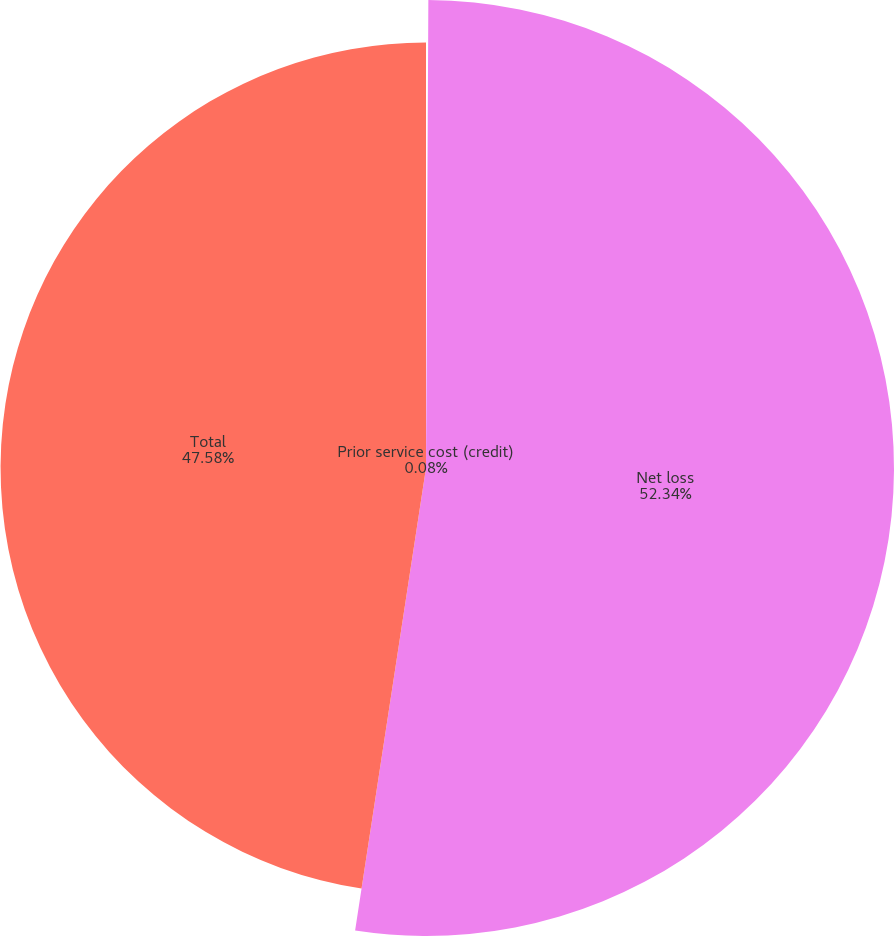Convert chart. <chart><loc_0><loc_0><loc_500><loc_500><pie_chart><fcel>Prior service cost (credit)<fcel>Net loss<fcel>Total<nl><fcel>0.08%<fcel>52.34%<fcel>47.58%<nl></chart> 